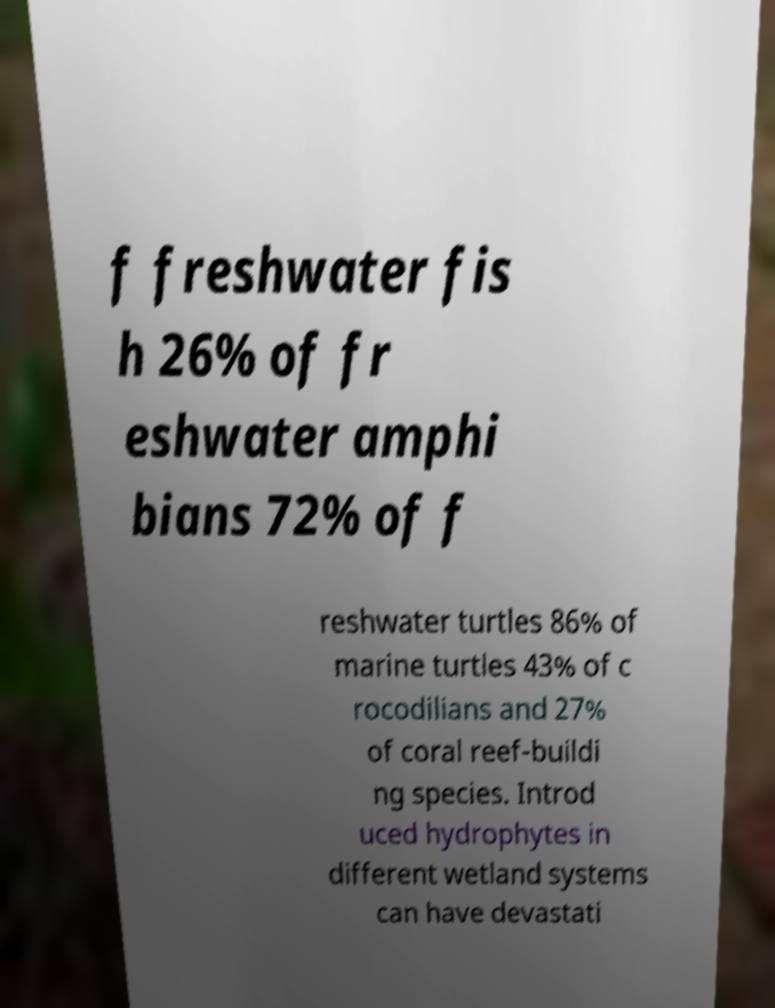Could you extract and type out the text from this image? f freshwater fis h 26% of fr eshwater amphi bians 72% of f reshwater turtles 86% of marine turtles 43% of c rocodilians and 27% of coral reef-buildi ng species. Introd uced hydrophytes in different wetland systems can have devastati 